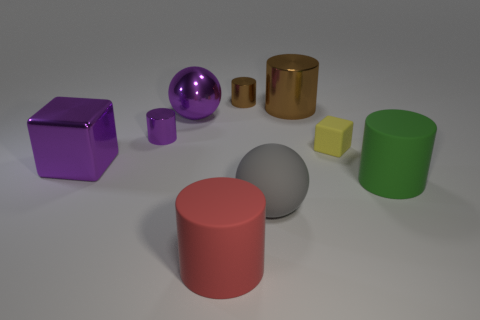Subtract all green cylinders. How many cylinders are left? 4 Subtract all purple cylinders. How many cylinders are left? 4 Subtract all blue cylinders. Subtract all yellow spheres. How many cylinders are left? 5 Add 1 red matte things. How many objects exist? 10 Subtract all balls. How many objects are left? 7 Add 9 gray things. How many gray things are left? 10 Add 2 large rubber cylinders. How many large rubber cylinders exist? 4 Subtract 0 blue cubes. How many objects are left? 9 Subtract all tiny brown shiny things. Subtract all small gray matte spheres. How many objects are left? 8 